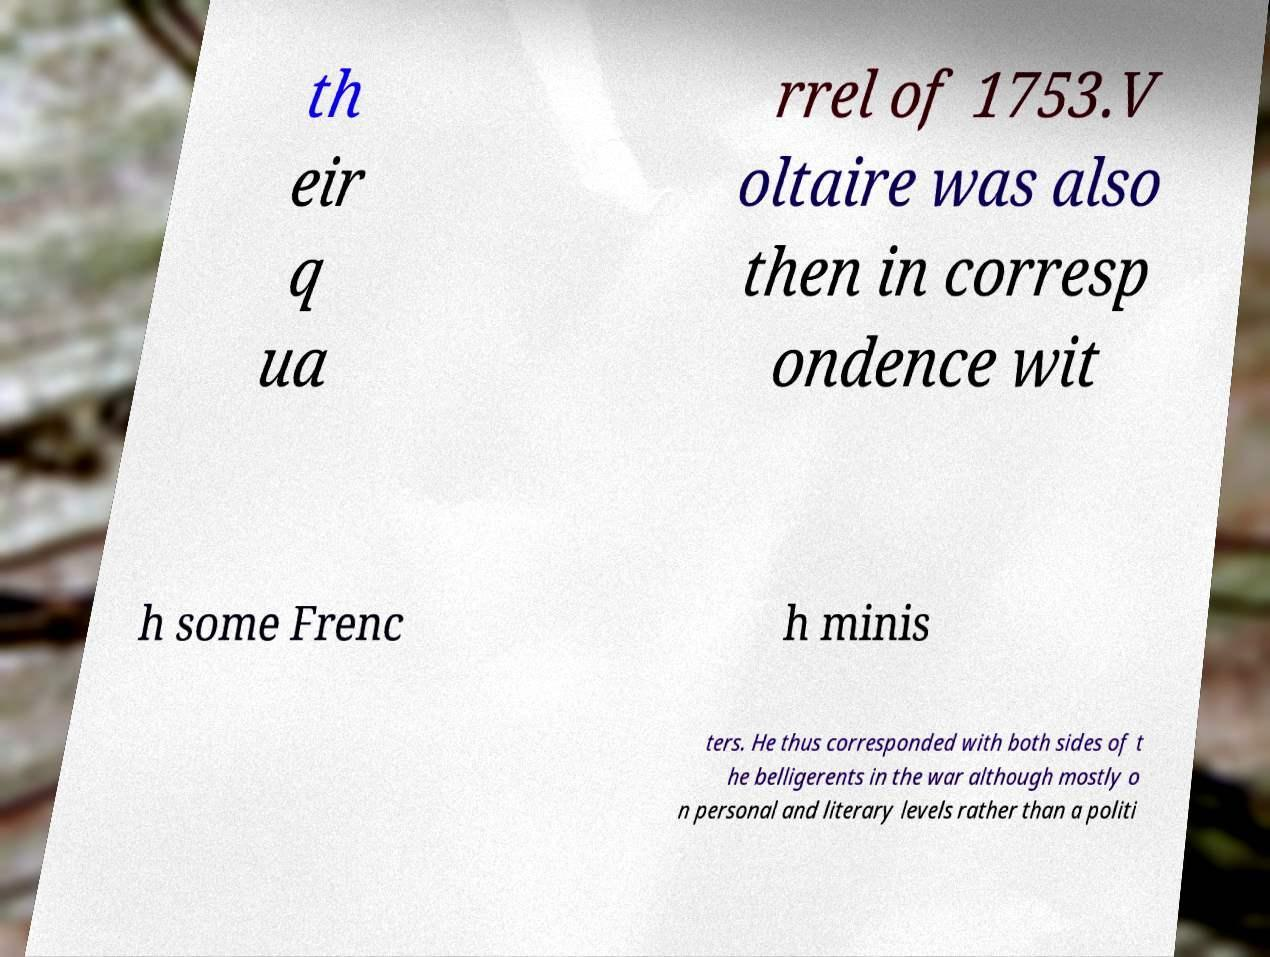I need the written content from this picture converted into text. Can you do that? th eir q ua rrel of 1753.V oltaire was also then in corresp ondence wit h some Frenc h minis ters. He thus corresponded with both sides of t he belligerents in the war although mostly o n personal and literary levels rather than a politi 